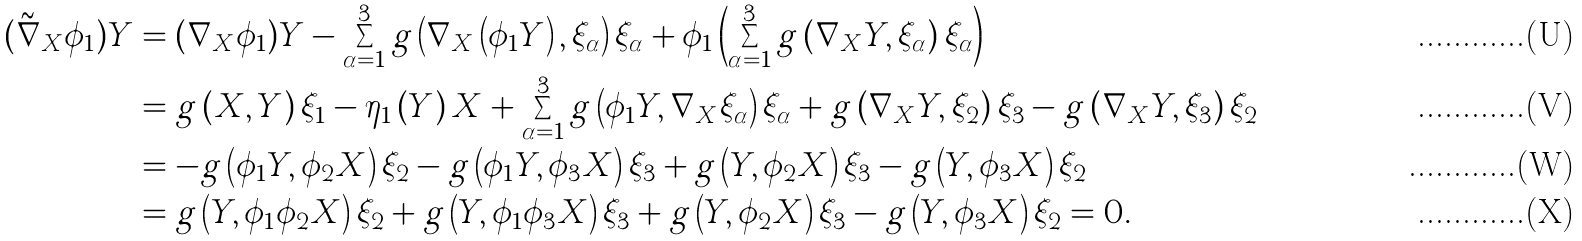<formula> <loc_0><loc_0><loc_500><loc_500>( \tilde { \nabla } _ { X } \phi _ { 1 } ) Y & = ( \nabla _ { X } \phi _ { 1 } ) Y - \sum _ { \alpha = 1 } ^ { 3 } g \left ( \nabla _ { X } \left ( \phi _ { 1 } Y \right ) , \xi _ { \alpha } \right ) \xi _ { \alpha } + \phi _ { 1 } \left ( \sum _ { \alpha = 1 } ^ { 3 } g \left ( \nabla _ { X } Y , \xi _ { \alpha } \right ) \xi _ { \alpha } \right ) \\ & = g \left ( X , Y \right ) \xi _ { 1 } - \eta _ { 1 } \left ( Y \right ) X + \sum _ { \alpha = 1 } ^ { 3 } g \left ( \phi _ { 1 } Y , \nabla _ { X } \xi _ { \alpha } \right ) \xi _ { \alpha } + g \left ( \nabla _ { X } Y , \xi _ { 2 } \right ) \xi _ { 3 } - g \left ( \nabla _ { X } Y , \xi _ { 3 } \right ) \xi _ { 2 } \\ & = - g \left ( \phi _ { 1 } Y , \phi _ { 2 } X \right ) \xi _ { 2 } - g \left ( \phi _ { 1 } Y , \phi _ { 3 } X \right ) \xi _ { 3 } + g \left ( Y , \phi _ { 2 } X \right ) \xi _ { 3 } - g \left ( Y , \phi _ { 3 } X \right ) \xi _ { 2 } \\ & = g \left ( Y , \phi _ { 1 } \phi _ { 2 } X \right ) \xi _ { 2 } + g \left ( Y , \phi _ { 1 } \phi _ { 3 } X \right ) \xi _ { 3 } + g \left ( Y , \phi _ { 2 } X \right ) \xi _ { 3 } - g \left ( Y , \phi _ { 3 } X \right ) \xi _ { 2 } = 0 .</formula> 